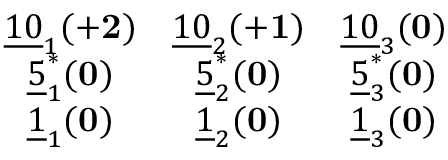<formula> <loc_0><loc_0><loc_500><loc_500>\begin{array} { c c c } { { \underline { 1 0 } _ { 1 } ( { + 2 } ) } } & { { \underline { 1 0 } _ { 2 } ( { + 1 } ) } } & { { \underline { 1 0 } _ { 3 } ( { 0 } ) } } \\ { { \underline { 5 } _ { 1 } ^ { * } ( { 0 } ) } } & { { \underline { 5 } _ { 2 } ^ { * } ( { 0 } ) } } & { { \underline { 5 } _ { 3 } ^ { * } ( { 0 } ) } } \\ { { \underline { 1 } _ { 1 } ( { 0 } ) } } & { { \underline { 1 } _ { 2 } ( { 0 } ) } } & { { \underline { 1 } _ { 3 } ( { 0 } ) } } \end{array}</formula> 